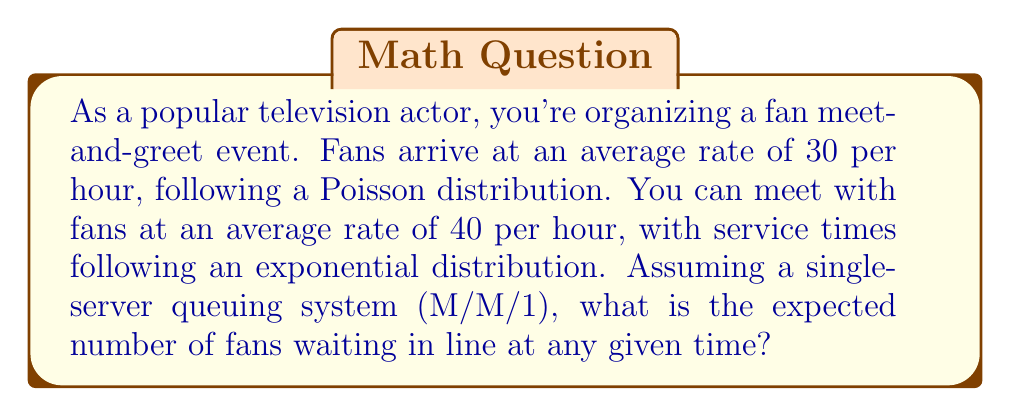What is the answer to this math problem? To solve this problem, we'll use the M/M/1 queuing model, where:

- M/M/1 denotes a single-server queue with Poisson arrivals and exponential service times
- $\lambda$ = arrival rate = 30 fans/hour
- $\mu$ = service rate = 40 fans/hour

Step 1: Calculate the utilization factor $\rho$
$$\rho = \frac{\lambda}{\mu} = \frac{30}{40} = 0.75$$

Step 2: Calculate the expected number of fans in the system $L$
$$L = \frac{\rho}{1-\rho} = \frac{0.75}{1-0.75} = 3$$

Step 3: Calculate the expected number of fans in the queue $L_q$
$$L_q = L - \rho = 3 - 0.75 = 2.25$$

The expected number of fans waiting in line (excluding the one being served) is $L_q = 2.25$.

This result can help you manage fan expectations and plan the event space accordingly. It also indicates that the system is stable ($\rho < 1$), meaning the queue won't grow infinitely long over time.
Answer: The expected number of fans waiting in line at any given time is 2.25. 